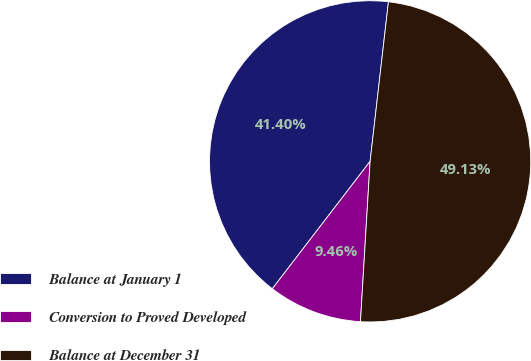<chart> <loc_0><loc_0><loc_500><loc_500><pie_chart><fcel>Balance at January 1<fcel>Conversion to Proved Developed<fcel>Balance at December 31<nl><fcel>41.4%<fcel>9.46%<fcel>49.13%<nl></chart> 